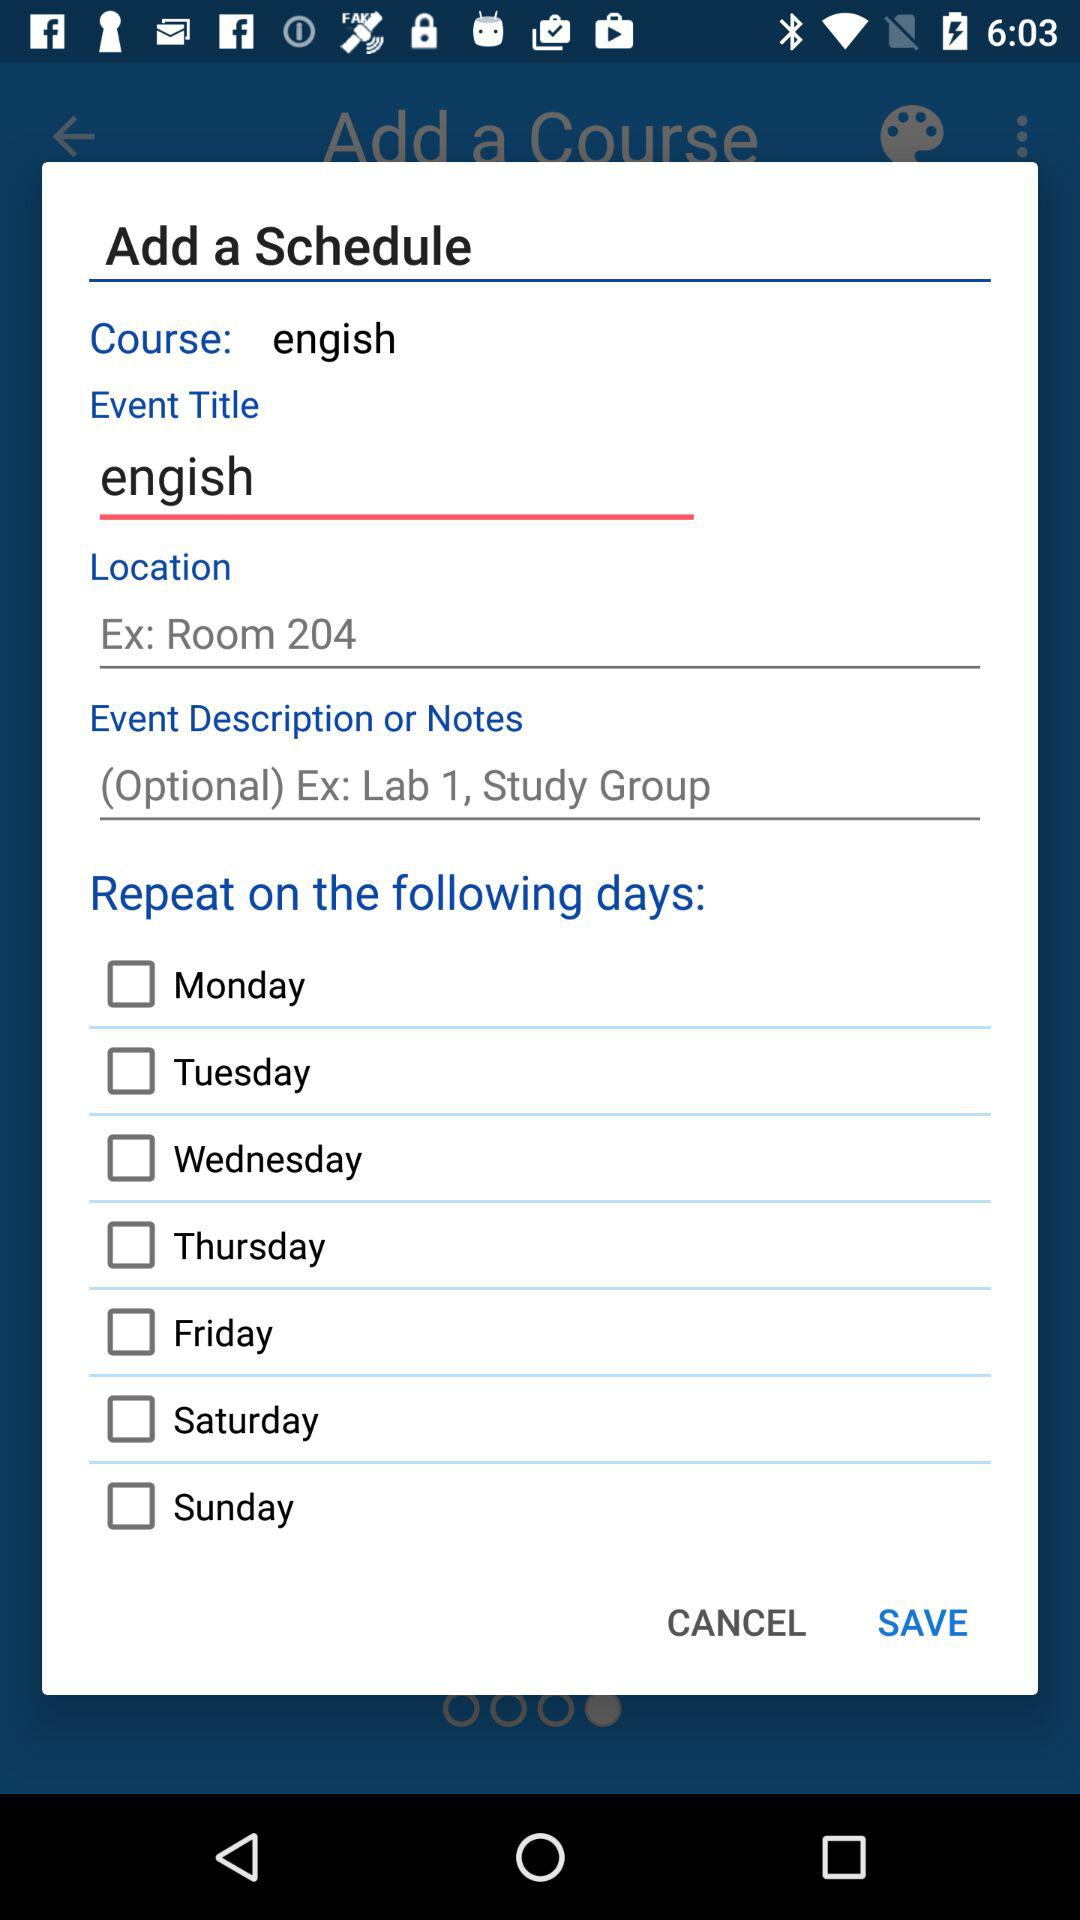What is the name of the location? The name of the location is Room 204. 